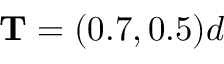<formula> <loc_0><loc_0><loc_500><loc_500>T = ( 0 . 7 , 0 . 5 ) d</formula> 